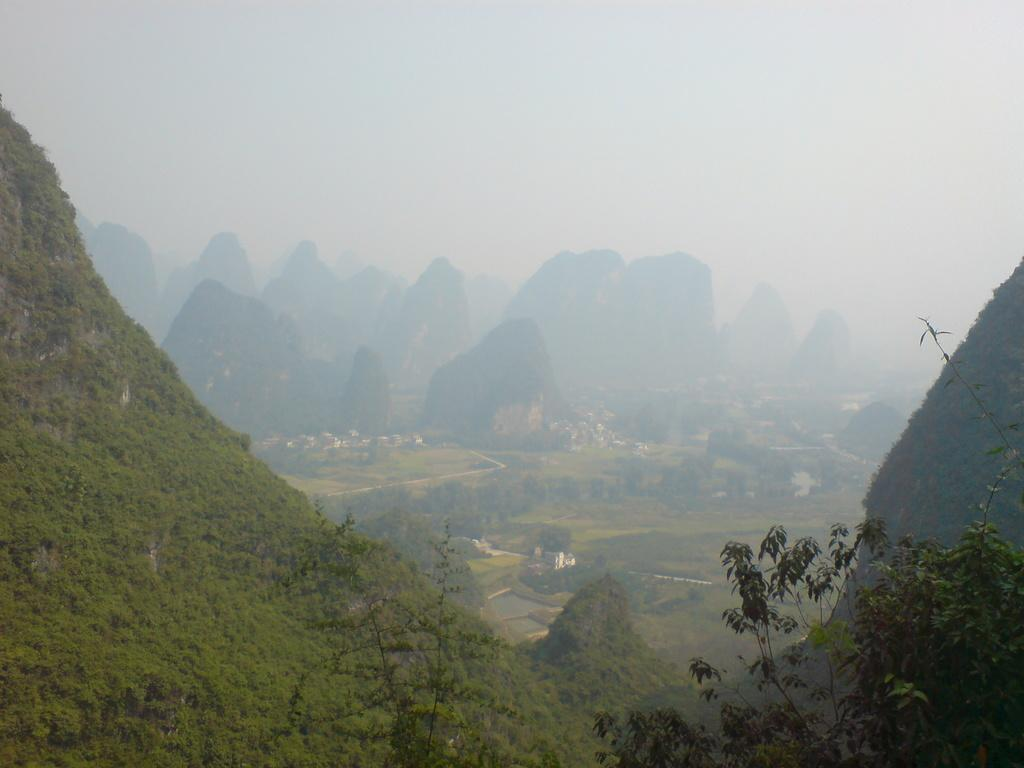What type of landscape is depicted in the image? The image features mountains. What can be seen on the mountains? There are trees on the mountains. How would you describe the sky in the image? The sky is foggy in the image. How many nets are visible on the mountains in the image? There are no nets visible on the mountains in the image. What type of cattle can be seen grazing on the mountains in the image? There are no cattle present in the image; it features mountains with trees and a foggy sky. 